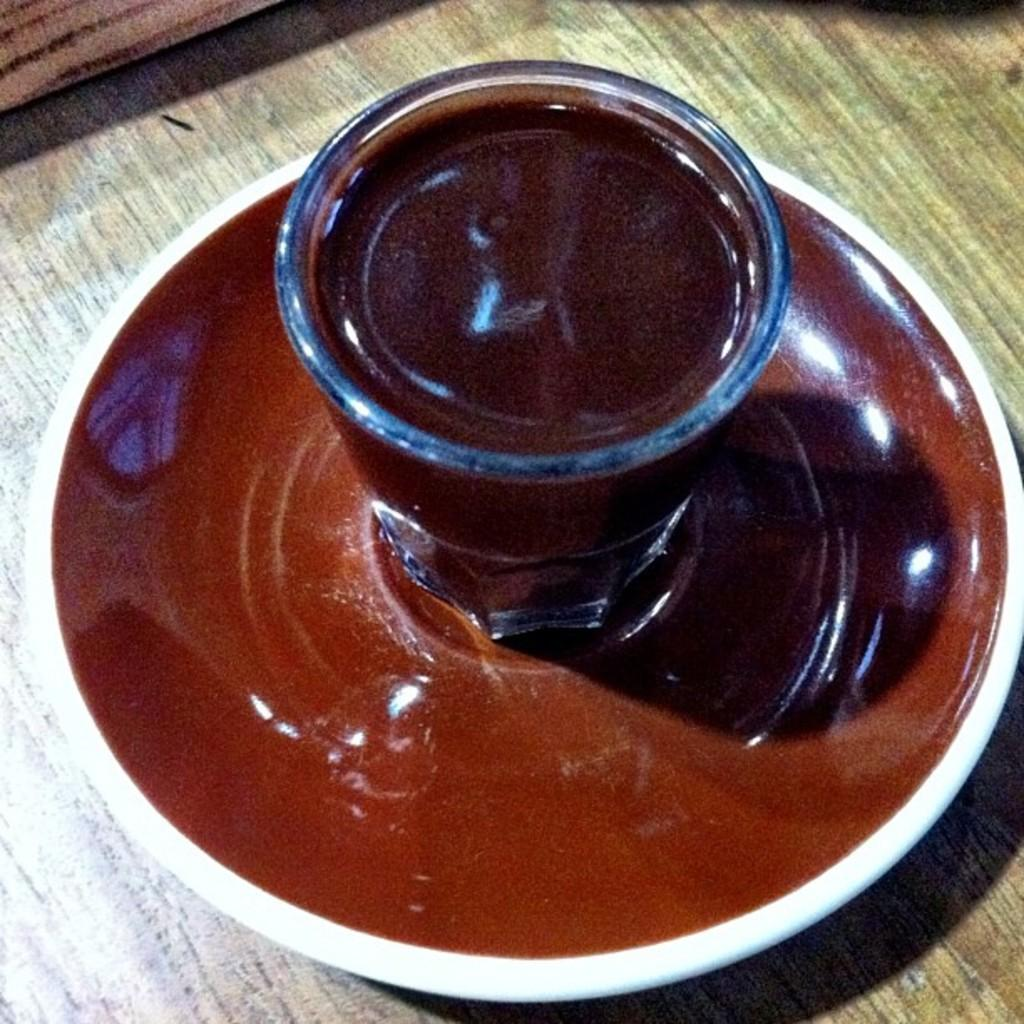What piece of furniture is present in the image? There is a table in the image. What is placed on the table? There is a plate and a glass on the table. What is inside the glass? The glass contains liquid. What decision is being made by the bed in the image? There is no bed present in the image, so no decision can be made by it. 